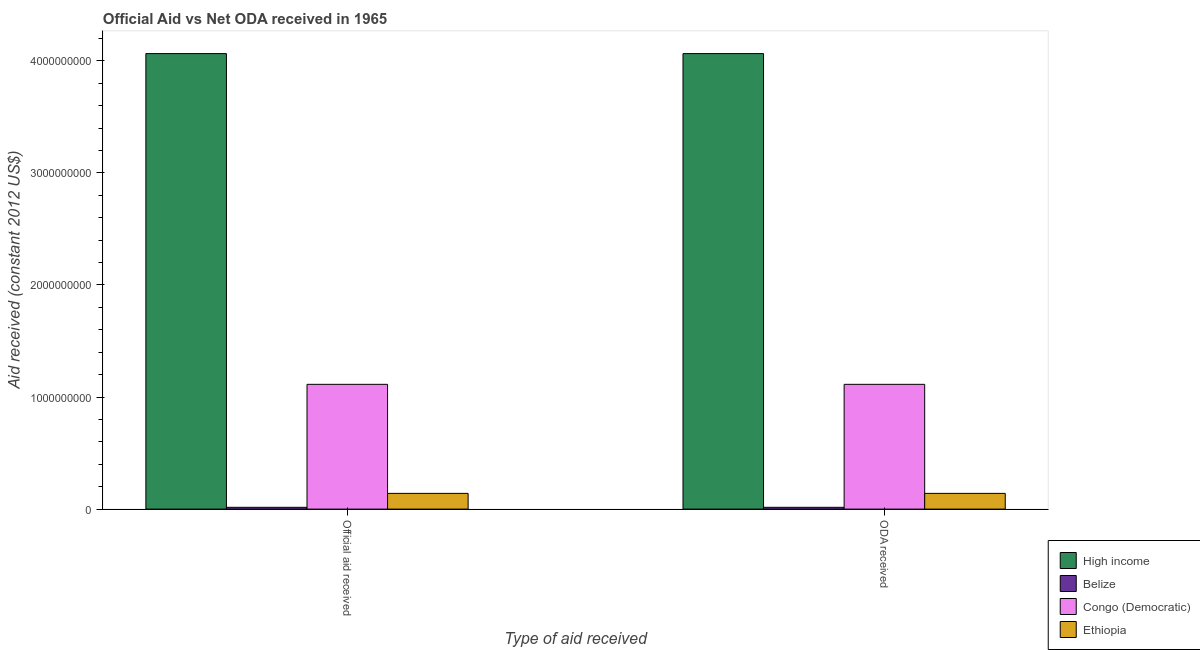How many different coloured bars are there?
Your response must be concise. 4. Are the number of bars on each tick of the X-axis equal?
Give a very brief answer. Yes. What is the label of the 1st group of bars from the left?
Your response must be concise. Official aid received. What is the oda received in High income?
Make the answer very short. 4.06e+09. Across all countries, what is the maximum oda received?
Make the answer very short. 4.06e+09. Across all countries, what is the minimum oda received?
Give a very brief answer. 1.60e+07. In which country was the official aid received minimum?
Make the answer very short. Belize. What is the total oda received in the graph?
Make the answer very short. 5.33e+09. What is the difference between the oda received in Belize and that in Congo (Democratic)?
Provide a succinct answer. -1.10e+09. What is the difference between the oda received in Belize and the official aid received in Congo (Democratic)?
Your answer should be compact. -1.10e+09. What is the average oda received per country?
Provide a succinct answer. 1.33e+09. What is the difference between the oda received and official aid received in High income?
Give a very brief answer. 0. In how many countries, is the oda received greater than 1800000000 US$?
Offer a terse response. 1. What is the ratio of the oda received in Belize to that in High income?
Ensure brevity in your answer.  0. Is the oda received in Ethiopia less than that in Congo (Democratic)?
Give a very brief answer. Yes. What does the 1st bar from the left in ODA received represents?
Make the answer very short. High income. What does the 1st bar from the right in Official aid received represents?
Offer a very short reply. Ethiopia. Are all the bars in the graph horizontal?
Provide a succinct answer. No. How are the legend labels stacked?
Ensure brevity in your answer.  Vertical. What is the title of the graph?
Provide a short and direct response. Official Aid vs Net ODA received in 1965 . Does "Afghanistan" appear as one of the legend labels in the graph?
Give a very brief answer. No. What is the label or title of the X-axis?
Your response must be concise. Type of aid received. What is the label or title of the Y-axis?
Provide a succinct answer. Aid received (constant 2012 US$). What is the Aid received (constant 2012 US$) in High income in Official aid received?
Your answer should be very brief. 4.06e+09. What is the Aid received (constant 2012 US$) in Belize in Official aid received?
Your answer should be very brief. 1.60e+07. What is the Aid received (constant 2012 US$) in Congo (Democratic) in Official aid received?
Provide a succinct answer. 1.11e+09. What is the Aid received (constant 2012 US$) in Ethiopia in Official aid received?
Make the answer very short. 1.40e+08. What is the Aid received (constant 2012 US$) of High income in ODA received?
Your response must be concise. 4.06e+09. What is the Aid received (constant 2012 US$) in Belize in ODA received?
Give a very brief answer. 1.60e+07. What is the Aid received (constant 2012 US$) of Congo (Democratic) in ODA received?
Your answer should be very brief. 1.11e+09. What is the Aid received (constant 2012 US$) of Ethiopia in ODA received?
Provide a succinct answer. 1.40e+08. Across all Type of aid received, what is the maximum Aid received (constant 2012 US$) of High income?
Ensure brevity in your answer.  4.06e+09. Across all Type of aid received, what is the maximum Aid received (constant 2012 US$) of Belize?
Provide a short and direct response. 1.60e+07. Across all Type of aid received, what is the maximum Aid received (constant 2012 US$) in Congo (Democratic)?
Ensure brevity in your answer.  1.11e+09. Across all Type of aid received, what is the maximum Aid received (constant 2012 US$) in Ethiopia?
Give a very brief answer. 1.40e+08. Across all Type of aid received, what is the minimum Aid received (constant 2012 US$) in High income?
Your response must be concise. 4.06e+09. Across all Type of aid received, what is the minimum Aid received (constant 2012 US$) of Belize?
Offer a very short reply. 1.60e+07. Across all Type of aid received, what is the minimum Aid received (constant 2012 US$) of Congo (Democratic)?
Your response must be concise. 1.11e+09. Across all Type of aid received, what is the minimum Aid received (constant 2012 US$) of Ethiopia?
Your response must be concise. 1.40e+08. What is the total Aid received (constant 2012 US$) of High income in the graph?
Offer a very short reply. 8.13e+09. What is the total Aid received (constant 2012 US$) in Belize in the graph?
Your answer should be compact. 3.19e+07. What is the total Aid received (constant 2012 US$) of Congo (Democratic) in the graph?
Your response must be concise. 2.23e+09. What is the total Aid received (constant 2012 US$) of Ethiopia in the graph?
Ensure brevity in your answer.  2.81e+08. What is the difference between the Aid received (constant 2012 US$) in High income in Official aid received and that in ODA received?
Ensure brevity in your answer.  0. What is the difference between the Aid received (constant 2012 US$) in High income in Official aid received and the Aid received (constant 2012 US$) in Belize in ODA received?
Offer a very short reply. 4.05e+09. What is the difference between the Aid received (constant 2012 US$) in High income in Official aid received and the Aid received (constant 2012 US$) in Congo (Democratic) in ODA received?
Offer a very short reply. 2.95e+09. What is the difference between the Aid received (constant 2012 US$) in High income in Official aid received and the Aid received (constant 2012 US$) in Ethiopia in ODA received?
Offer a terse response. 3.92e+09. What is the difference between the Aid received (constant 2012 US$) of Belize in Official aid received and the Aid received (constant 2012 US$) of Congo (Democratic) in ODA received?
Offer a very short reply. -1.10e+09. What is the difference between the Aid received (constant 2012 US$) of Belize in Official aid received and the Aid received (constant 2012 US$) of Ethiopia in ODA received?
Provide a succinct answer. -1.24e+08. What is the difference between the Aid received (constant 2012 US$) of Congo (Democratic) in Official aid received and the Aid received (constant 2012 US$) of Ethiopia in ODA received?
Your response must be concise. 9.73e+08. What is the average Aid received (constant 2012 US$) of High income per Type of aid received?
Provide a succinct answer. 4.06e+09. What is the average Aid received (constant 2012 US$) in Belize per Type of aid received?
Offer a terse response. 1.60e+07. What is the average Aid received (constant 2012 US$) of Congo (Democratic) per Type of aid received?
Offer a terse response. 1.11e+09. What is the average Aid received (constant 2012 US$) in Ethiopia per Type of aid received?
Ensure brevity in your answer.  1.40e+08. What is the difference between the Aid received (constant 2012 US$) of High income and Aid received (constant 2012 US$) of Belize in Official aid received?
Keep it short and to the point. 4.05e+09. What is the difference between the Aid received (constant 2012 US$) in High income and Aid received (constant 2012 US$) in Congo (Democratic) in Official aid received?
Your answer should be very brief. 2.95e+09. What is the difference between the Aid received (constant 2012 US$) in High income and Aid received (constant 2012 US$) in Ethiopia in Official aid received?
Your response must be concise. 3.92e+09. What is the difference between the Aid received (constant 2012 US$) of Belize and Aid received (constant 2012 US$) of Congo (Democratic) in Official aid received?
Provide a succinct answer. -1.10e+09. What is the difference between the Aid received (constant 2012 US$) in Belize and Aid received (constant 2012 US$) in Ethiopia in Official aid received?
Make the answer very short. -1.24e+08. What is the difference between the Aid received (constant 2012 US$) in Congo (Democratic) and Aid received (constant 2012 US$) in Ethiopia in Official aid received?
Offer a terse response. 9.73e+08. What is the difference between the Aid received (constant 2012 US$) of High income and Aid received (constant 2012 US$) of Belize in ODA received?
Your answer should be very brief. 4.05e+09. What is the difference between the Aid received (constant 2012 US$) of High income and Aid received (constant 2012 US$) of Congo (Democratic) in ODA received?
Your response must be concise. 2.95e+09. What is the difference between the Aid received (constant 2012 US$) in High income and Aid received (constant 2012 US$) in Ethiopia in ODA received?
Provide a short and direct response. 3.92e+09. What is the difference between the Aid received (constant 2012 US$) of Belize and Aid received (constant 2012 US$) of Congo (Democratic) in ODA received?
Your answer should be compact. -1.10e+09. What is the difference between the Aid received (constant 2012 US$) in Belize and Aid received (constant 2012 US$) in Ethiopia in ODA received?
Provide a short and direct response. -1.24e+08. What is the difference between the Aid received (constant 2012 US$) in Congo (Democratic) and Aid received (constant 2012 US$) in Ethiopia in ODA received?
Make the answer very short. 9.73e+08. What is the ratio of the Aid received (constant 2012 US$) in High income in Official aid received to that in ODA received?
Give a very brief answer. 1. What is the ratio of the Aid received (constant 2012 US$) of Congo (Democratic) in Official aid received to that in ODA received?
Ensure brevity in your answer.  1. What is the ratio of the Aid received (constant 2012 US$) of Ethiopia in Official aid received to that in ODA received?
Make the answer very short. 1. What is the difference between the highest and the lowest Aid received (constant 2012 US$) of High income?
Your answer should be very brief. 0. What is the difference between the highest and the lowest Aid received (constant 2012 US$) of Belize?
Your answer should be very brief. 0. What is the difference between the highest and the lowest Aid received (constant 2012 US$) in Congo (Democratic)?
Keep it short and to the point. 0. 